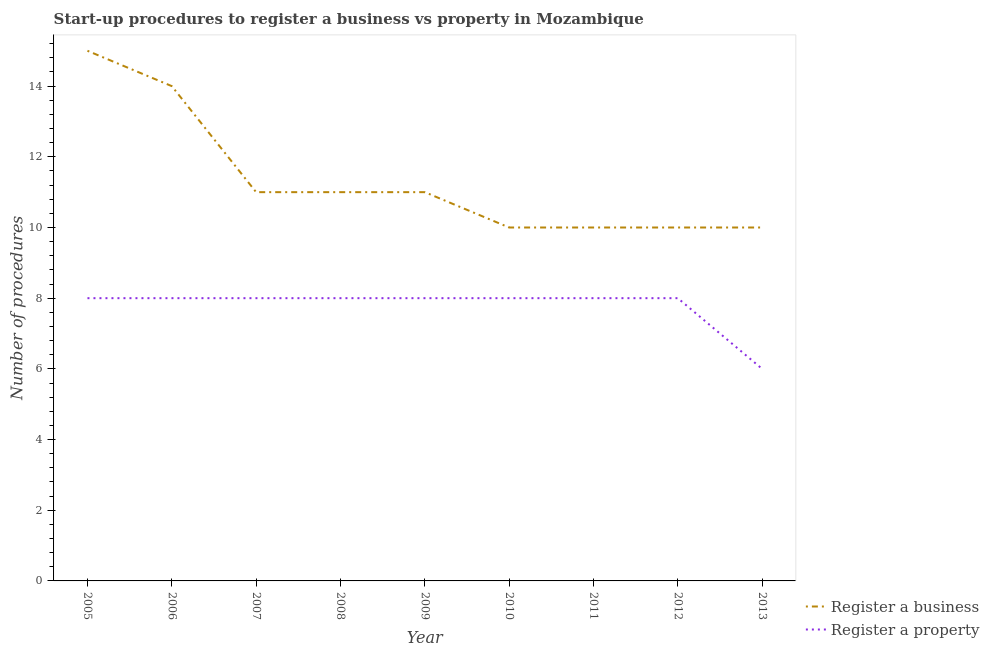How many different coloured lines are there?
Ensure brevity in your answer.  2. Does the line corresponding to number of procedures to register a property intersect with the line corresponding to number of procedures to register a business?
Your response must be concise. No. Is the number of lines equal to the number of legend labels?
Your response must be concise. Yes. What is the number of procedures to register a property in 2008?
Provide a short and direct response. 8. Across all years, what is the maximum number of procedures to register a property?
Provide a succinct answer. 8. Across all years, what is the minimum number of procedures to register a business?
Your response must be concise. 10. In which year was the number of procedures to register a business maximum?
Your answer should be very brief. 2005. What is the total number of procedures to register a business in the graph?
Your response must be concise. 102. What is the difference between the number of procedures to register a property in 2006 and that in 2009?
Offer a very short reply. 0. What is the average number of procedures to register a business per year?
Offer a terse response. 11.33. In the year 2009, what is the difference between the number of procedures to register a property and number of procedures to register a business?
Your answer should be compact. -3. What is the difference between the highest and the lowest number of procedures to register a business?
Give a very brief answer. 5. In how many years, is the number of procedures to register a business greater than the average number of procedures to register a business taken over all years?
Make the answer very short. 2. Does the number of procedures to register a business monotonically increase over the years?
Provide a short and direct response. No. Is the number of procedures to register a property strictly greater than the number of procedures to register a business over the years?
Offer a terse response. No. Is the number of procedures to register a business strictly less than the number of procedures to register a property over the years?
Ensure brevity in your answer.  No. How many years are there in the graph?
Provide a succinct answer. 9. What is the difference between two consecutive major ticks on the Y-axis?
Offer a very short reply. 2. Does the graph contain grids?
Ensure brevity in your answer.  No. What is the title of the graph?
Provide a short and direct response. Start-up procedures to register a business vs property in Mozambique. What is the label or title of the X-axis?
Give a very brief answer. Year. What is the label or title of the Y-axis?
Your answer should be compact. Number of procedures. What is the Number of procedures of Register a business in 2005?
Ensure brevity in your answer.  15. What is the Number of procedures in Register a property in 2005?
Keep it short and to the point. 8. What is the Number of procedures in Register a business in 2006?
Your answer should be compact. 14. What is the Number of procedures of Register a business in 2008?
Offer a very short reply. 11. What is the Number of procedures of Register a property in 2008?
Give a very brief answer. 8. What is the Number of procedures of Register a business in 2009?
Keep it short and to the point. 11. What is the Number of procedures of Register a property in 2009?
Your response must be concise. 8. What is the Number of procedures in Register a property in 2010?
Provide a short and direct response. 8. What is the Number of procedures of Register a property in 2011?
Your answer should be very brief. 8. What is the Number of procedures in Register a property in 2012?
Give a very brief answer. 8. What is the Number of procedures of Register a business in 2013?
Keep it short and to the point. 10. Across all years, what is the maximum Number of procedures of Register a business?
Make the answer very short. 15. Across all years, what is the maximum Number of procedures of Register a property?
Your response must be concise. 8. Across all years, what is the minimum Number of procedures of Register a business?
Provide a short and direct response. 10. Across all years, what is the minimum Number of procedures in Register a property?
Offer a terse response. 6. What is the total Number of procedures of Register a business in the graph?
Your answer should be very brief. 102. What is the total Number of procedures of Register a property in the graph?
Your response must be concise. 70. What is the difference between the Number of procedures in Register a business in 2005 and that in 2007?
Provide a succinct answer. 4. What is the difference between the Number of procedures of Register a business in 2005 and that in 2009?
Give a very brief answer. 4. What is the difference between the Number of procedures of Register a business in 2005 and that in 2010?
Give a very brief answer. 5. What is the difference between the Number of procedures in Register a business in 2005 and that in 2011?
Give a very brief answer. 5. What is the difference between the Number of procedures of Register a property in 2005 and that in 2011?
Your response must be concise. 0. What is the difference between the Number of procedures in Register a business in 2005 and that in 2012?
Give a very brief answer. 5. What is the difference between the Number of procedures of Register a property in 2005 and that in 2012?
Provide a short and direct response. 0. What is the difference between the Number of procedures of Register a business in 2005 and that in 2013?
Provide a short and direct response. 5. What is the difference between the Number of procedures of Register a business in 2006 and that in 2007?
Ensure brevity in your answer.  3. What is the difference between the Number of procedures of Register a property in 2006 and that in 2007?
Offer a terse response. 0. What is the difference between the Number of procedures of Register a property in 2006 and that in 2008?
Your answer should be very brief. 0. What is the difference between the Number of procedures in Register a business in 2006 and that in 2009?
Provide a short and direct response. 3. What is the difference between the Number of procedures in Register a business in 2006 and that in 2011?
Keep it short and to the point. 4. What is the difference between the Number of procedures in Register a business in 2006 and that in 2012?
Offer a terse response. 4. What is the difference between the Number of procedures of Register a property in 2006 and that in 2012?
Offer a very short reply. 0. What is the difference between the Number of procedures in Register a business in 2006 and that in 2013?
Give a very brief answer. 4. What is the difference between the Number of procedures in Register a business in 2007 and that in 2008?
Offer a very short reply. 0. What is the difference between the Number of procedures of Register a business in 2007 and that in 2009?
Your answer should be compact. 0. What is the difference between the Number of procedures in Register a property in 2007 and that in 2009?
Offer a very short reply. 0. What is the difference between the Number of procedures in Register a property in 2007 and that in 2010?
Offer a very short reply. 0. What is the difference between the Number of procedures of Register a business in 2007 and that in 2011?
Make the answer very short. 1. What is the difference between the Number of procedures of Register a property in 2007 and that in 2011?
Your answer should be compact. 0. What is the difference between the Number of procedures in Register a business in 2007 and that in 2012?
Keep it short and to the point. 1. What is the difference between the Number of procedures in Register a property in 2007 and that in 2012?
Provide a succinct answer. 0. What is the difference between the Number of procedures of Register a business in 2008 and that in 2009?
Your response must be concise. 0. What is the difference between the Number of procedures in Register a property in 2008 and that in 2009?
Ensure brevity in your answer.  0. What is the difference between the Number of procedures in Register a business in 2008 and that in 2012?
Your answer should be very brief. 1. What is the difference between the Number of procedures of Register a property in 2008 and that in 2012?
Ensure brevity in your answer.  0. What is the difference between the Number of procedures of Register a business in 2009 and that in 2011?
Provide a short and direct response. 1. What is the difference between the Number of procedures of Register a property in 2009 and that in 2011?
Provide a succinct answer. 0. What is the difference between the Number of procedures of Register a business in 2009 and that in 2013?
Provide a succinct answer. 1. What is the difference between the Number of procedures of Register a business in 2010 and that in 2011?
Offer a terse response. 0. What is the difference between the Number of procedures in Register a property in 2010 and that in 2011?
Offer a terse response. 0. What is the difference between the Number of procedures of Register a business in 2010 and that in 2012?
Provide a succinct answer. 0. What is the difference between the Number of procedures in Register a business in 2010 and that in 2013?
Offer a very short reply. 0. What is the difference between the Number of procedures of Register a business in 2011 and that in 2012?
Offer a terse response. 0. What is the difference between the Number of procedures in Register a property in 2011 and that in 2012?
Make the answer very short. 0. What is the difference between the Number of procedures of Register a property in 2011 and that in 2013?
Your response must be concise. 2. What is the difference between the Number of procedures of Register a property in 2012 and that in 2013?
Ensure brevity in your answer.  2. What is the difference between the Number of procedures in Register a business in 2005 and the Number of procedures in Register a property in 2008?
Offer a terse response. 7. What is the difference between the Number of procedures of Register a business in 2005 and the Number of procedures of Register a property in 2011?
Offer a very short reply. 7. What is the difference between the Number of procedures of Register a business in 2005 and the Number of procedures of Register a property in 2012?
Offer a very short reply. 7. What is the difference between the Number of procedures of Register a business in 2006 and the Number of procedures of Register a property in 2009?
Your answer should be very brief. 6. What is the difference between the Number of procedures in Register a business in 2006 and the Number of procedures in Register a property in 2010?
Offer a terse response. 6. What is the difference between the Number of procedures in Register a business in 2006 and the Number of procedures in Register a property in 2011?
Offer a very short reply. 6. What is the difference between the Number of procedures in Register a business in 2006 and the Number of procedures in Register a property in 2012?
Your response must be concise. 6. What is the difference between the Number of procedures of Register a business in 2006 and the Number of procedures of Register a property in 2013?
Provide a short and direct response. 8. What is the difference between the Number of procedures of Register a business in 2007 and the Number of procedures of Register a property in 2008?
Ensure brevity in your answer.  3. What is the difference between the Number of procedures of Register a business in 2007 and the Number of procedures of Register a property in 2010?
Ensure brevity in your answer.  3. What is the difference between the Number of procedures of Register a business in 2007 and the Number of procedures of Register a property in 2013?
Make the answer very short. 5. What is the difference between the Number of procedures of Register a business in 2008 and the Number of procedures of Register a property in 2010?
Your answer should be compact. 3. What is the difference between the Number of procedures in Register a business in 2008 and the Number of procedures in Register a property in 2011?
Keep it short and to the point. 3. What is the difference between the Number of procedures in Register a business in 2009 and the Number of procedures in Register a property in 2010?
Provide a succinct answer. 3. What is the difference between the Number of procedures of Register a business in 2009 and the Number of procedures of Register a property in 2011?
Make the answer very short. 3. What is the difference between the Number of procedures of Register a business in 2010 and the Number of procedures of Register a property in 2011?
Your answer should be compact. 2. What is the difference between the Number of procedures of Register a business in 2010 and the Number of procedures of Register a property in 2013?
Ensure brevity in your answer.  4. What is the difference between the Number of procedures of Register a business in 2011 and the Number of procedures of Register a property in 2013?
Offer a very short reply. 4. What is the average Number of procedures of Register a business per year?
Your answer should be compact. 11.33. What is the average Number of procedures of Register a property per year?
Your answer should be very brief. 7.78. In the year 2005, what is the difference between the Number of procedures of Register a business and Number of procedures of Register a property?
Give a very brief answer. 7. In the year 2006, what is the difference between the Number of procedures in Register a business and Number of procedures in Register a property?
Ensure brevity in your answer.  6. In the year 2007, what is the difference between the Number of procedures of Register a business and Number of procedures of Register a property?
Offer a very short reply. 3. In the year 2011, what is the difference between the Number of procedures in Register a business and Number of procedures in Register a property?
Your answer should be very brief. 2. What is the ratio of the Number of procedures of Register a business in 2005 to that in 2006?
Keep it short and to the point. 1.07. What is the ratio of the Number of procedures in Register a property in 2005 to that in 2006?
Your answer should be very brief. 1. What is the ratio of the Number of procedures in Register a business in 2005 to that in 2007?
Provide a succinct answer. 1.36. What is the ratio of the Number of procedures of Register a business in 2005 to that in 2008?
Your answer should be very brief. 1.36. What is the ratio of the Number of procedures in Register a business in 2005 to that in 2009?
Provide a succinct answer. 1.36. What is the ratio of the Number of procedures in Register a business in 2005 to that in 2010?
Make the answer very short. 1.5. What is the ratio of the Number of procedures in Register a property in 2005 to that in 2011?
Your answer should be very brief. 1. What is the ratio of the Number of procedures in Register a property in 2005 to that in 2012?
Provide a succinct answer. 1. What is the ratio of the Number of procedures of Register a business in 2006 to that in 2007?
Provide a short and direct response. 1.27. What is the ratio of the Number of procedures of Register a business in 2006 to that in 2008?
Provide a succinct answer. 1.27. What is the ratio of the Number of procedures of Register a business in 2006 to that in 2009?
Keep it short and to the point. 1.27. What is the ratio of the Number of procedures in Register a property in 2006 to that in 2011?
Your answer should be very brief. 1. What is the ratio of the Number of procedures of Register a business in 2006 to that in 2012?
Your response must be concise. 1.4. What is the ratio of the Number of procedures of Register a business in 2006 to that in 2013?
Give a very brief answer. 1.4. What is the ratio of the Number of procedures in Register a property in 2006 to that in 2013?
Provide a succinct answer. 1.33. What is the ratio of the Number of procedures in Register a property in 2007 to that in 2008?
Make the answer very short. 1. What is the ratio of the Number of procedures in Register a business in 2007 to that in 2009?
Provide a short and direct response. 1. What is the ratio of the Number of procedures of Register a property in 2007 to that in 2009?
Your answer should be very brief. 1. What is the ratio of the Number of procedures in Register a business in 2007 to that in 2013?
Keep it short and to the point. 1.1. What is the ratio of the Number of procedures in Register a property in 2008 to that in 2009?
Offer a terse response. 1. What is the ratio of the Number of procedures of Register a business in 2008 to that in 2010?
Make the answer very short. 1.1. What is the ratio of the Number of procedures of Register a business in 2008 to that in 2012?
Provide a succinct answer. 1.1. What is the ratio of the Number of procedures in Register a property in 2008 to that in 2013?
Ensure brevity in your answer.  1.33. What is the ratio of the Number of procedures in Register a business in 2009 to that in 2011?
Your response must be concise. 1.1. What is the ratio of the Number of procedures of Register a property in 2009 to that in 2011?
Offer a terse response. 1. What is the ratio of the Number of procedures of Register a property in 2009 to that in 2012?
Offer a very short reply. 1. What is the ratio of the Number of procedures of Register a business in 2009 to that in 2013?
Offer a very short reply. 1.1. What is the ratio of the Number of procedures in Register a business in 2010 to that in 2011?
Your response must be concise. 1. What is the ratio of the Number of procedures of Register a property in 2010 to that in 2011?
Offer a very short reply. 1. What is the ratio of the Number of procedures of Register a business in 2010 to that in 2012?
Your answer should be very brief. 1. What is the ratio of the Number of procedures in Register a business in 2012 to that in 2013?
Give a very brief answer. 1. What is the difference between the highest and the second highest Number of procedures of Register a business?
Your response must be concise. 1. What is the difference between the highest and the lowest Number of procedures of Register a property?
Offer a terse response. 2. 